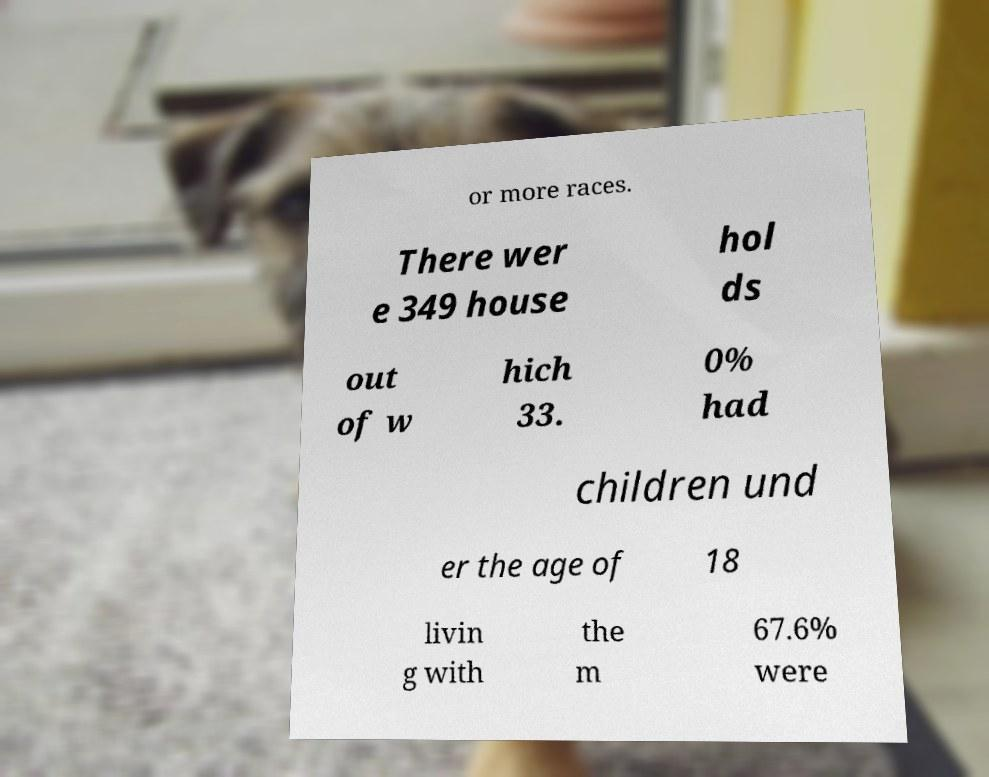What messages or text are displayed in this image? I need them in a readable, typed format. or more races. There wer e 349 house hol ds out of w hich 33. 0% had children und er the age of 18 livin g with the m 67.6% were 